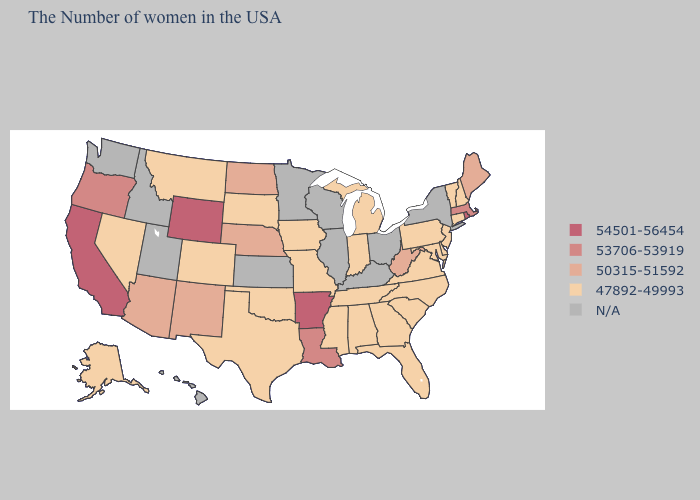What is the value of Louisiana?
Write a very short answer. 53706-53919. What is the lowest value in states that border Iowa?
Be succinct. 47892-49993. Among the states that border South Carolina , which have the highest value?
Short answer required. North Carolina, Georgia. Name the states that have a value in the range 54501-56454?
Answer briefly. Rhode Island, Arkansas, Wyoming, California. Among the states that border New Hampshire , which have the lowest value?
Write a very short answer. Vermont. What is the value of Idaho?
Write a very short answer. N/A. What is the highest value in the West ?
Answer briefly. 54501-56454. Does Rhode Island have the highest value in the USA?
Short answer required. Yes. Name the states that have a value in the range 50315-51592?
Answer briefly. Maine, West Virginia, Nebraska, North Dakota, New Mexico, Arizona. Among the states that border Louisiana , which have the highest value?
Quick response, please. Arkansas. Name the states that have a value in the range 54501-56454?
Be succinct. Rhode Island, Arkansas, Wyoming, California. Does Maine have the lowest value in the USA?
Keep it brief. No. What is the highest value in the USA?
Quick response, please. 54501-56454. Among the states that border New Mexico , does Arizona have the highest value?
Concise answer only. Yes. Which states have the lowest value in the South?
Write a very short answer. Delaware, Maryland, Virginia, North Carolina, South Carolina, Florida, Georgia, Alabama, Tennessee, Mississippi, Oklahoma, Texas. 